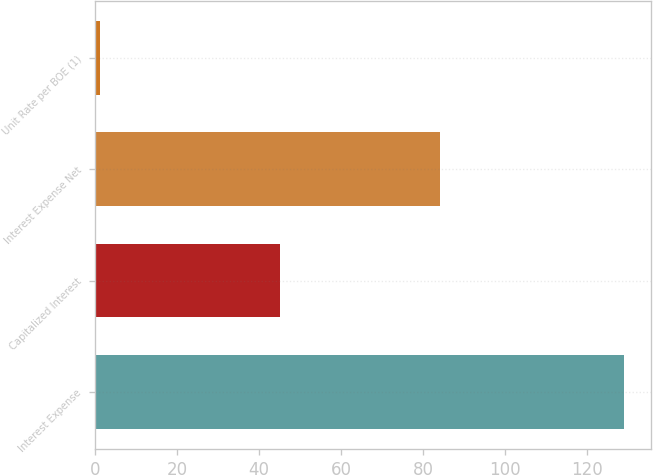<chart> <loc_0><loc_0><loc_500><loc_500><bar_chart><fcel>Interest Expense<fcel>Capitalized Interest<fcel>Interest Expense Net<fcel>Unit Rate per BOE (1)<nl><fcel>129<fcel>45<fcel>84<fcel>1.13<nl></chart> 